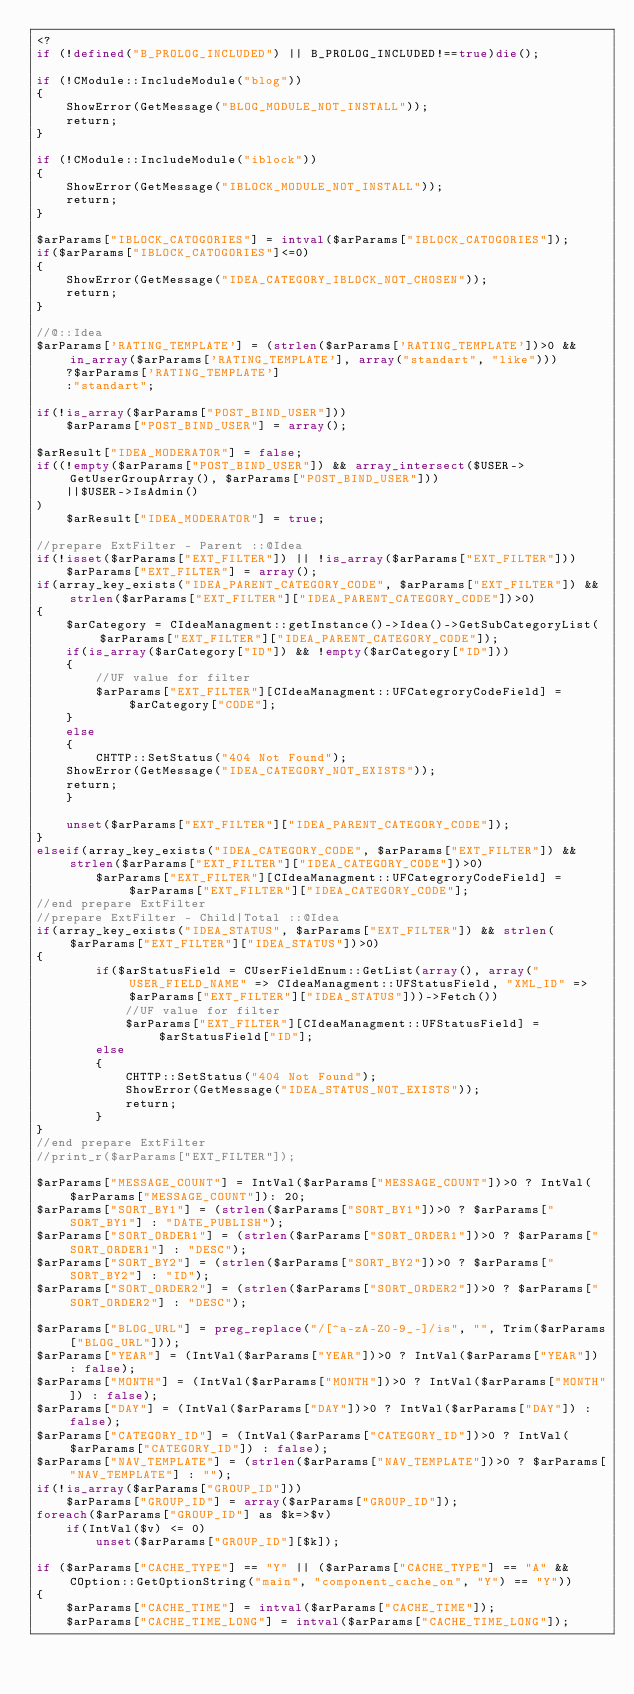<code> <loc_0><loc_0><loc_500><loc_500><_PHP_><?
if (!defined("B_PROLOG_INCLUDED") || B_PROLOG_INCLUDED!==true)die();

if (!CModule::IncludeModule("blog"))
{
	ShowError(GetMessage("BLOG_MODULE_NOT_INSTALL"));
	return;
}

if (!CModule::IncludeModule("iblock"))
{
	ShowError(GetMessage("IBLOCK_MODULE_NOT_INSTALL"));
	return;
}

$arParams["IBLOCK_CATOGORIES"] = intval($arParams["IBLOCK_CATOGORIES"]);
if($arParams["IBLOCK_CATOGORIES"]<=0)
{
	ShowError(GetMessage("IDEA_CATEGORY_IBLOCK_NOT_CHOSEN"));
	return;
}

//@::Idea
$arParams['RATING_TEMPLATE'] = (strlen($arParams['RATING_TEMPLATE'])>0 && in_array($arParams['RATING_TEMPLATE'], array("standart", "like")))
    ?$arParams['RATING_TEMPLATE']
    :"standart";

if(!is_array($arParams["POST_BIND_USER"]))
    $arParams["POST_BIND_USER"] = array();

$arResult["IDEA_MODERATOR"] = false;
if((!empty($arParams["POST_BIND_USER"]) && array_intersect($USER->GetUserGroupArray(), $arParams["POST_BIND_USER"]))
    ||$USER->IsAdmin()
)
    $arResult["IDEA_MODERATOR"] = true;

//prepare ExtFilter - Parent ::@Idea
if(!isset($arParams["EXT_FILTER"]) || !is_array($arParams["EXT_FILTER"]))
    $arParams["EXT_FILTER"] = array();
if(array_key_exists("IDEA_PARENT_CATEGORY_CODE", $arParams["EXT_FILTER"]) && strlen($arParams["EXT_FILTER"]["IDEA_PARENT_CATEGORY_CODE"])>0)
{
    $arCategory = CIdeaManagment::getInstance()->Idea()->GetSubCategoryList($arParams["EXT_FILTER"]["IDEA_PARENT_CATEGORY_CODE"]);
    if(is_array($arCategory["ID"]) && !empty($arCategory["ID"]))
    {
        //UF value for filter
        $arParams["EXT_FILTER"][CIdeaManagment::UFCategroryCodeField] = $arCategory["CODE"];
    }
    else
    {
        CHTTP::SetStatus("404 Not Found");
	ShowError(GetMessage("IDEA_CATEGORY_NOT_EXISTS"));
	return;
    }

    unset($arParams["EXT_FILTER"]["IDEA_PARENT_CATEGORY_CODE"]);
}
elseif(array_key_exists("IDEA_CATEGORY_CODE", $arParams["EXT_FILTER"]) && strlen($arParams["EXT_FILTER"]["IDEA_CATEGORY_CODE"])>0)
        $arParams["EXT_FILTER"][CIdeaManagment::UFCategroryCodeField] = $arParams["EXT_FILTER"]["IDEA_CATEGORY_CODE"];
//end prepare ExtFilter
//prepare ExtFilter - Child|Total ::@Idea
if(array_key_exists("IDEA_STATUS", $arParams["EXT_FILTER"]) && strlen($arParams["EXT_FILTER"]["IDEA_STATUS"])>0)
{ 
        if($arStatusField = CUserFieldEnum::GetList(array(), array("USER_FIELD_NAME" => CIdeaManagment::UFStatusField, "XML_ID" => $arParams["EXT_FILTER"]["IDEA_STATUS"]))->Fetch())
            //UF value for filter
            $arParams["EXT_FILTER"][CIdeaManagment::UFStatusField] = $arStatusField["ID"];
        else
        {
            CHTTP::SetStatus("404 Not Found");
            ShowError(GetMessage("IDEA_STATUS_NOT_EXISTS"));
            return;         
        }
}
//end prepare ExtFilter
//print_r($arParams["EXT_FILTER"]);

$arParams["MESSAGE_COUNT"] = IntVal($arParams["MESSAGE_COUNT"])>0 ? IntVal($arParams["MESSAGE_COUNT"]): 20;
$arParams["SORT_BY1"] = (strlen($arParams["SORT_BY1"])>0 ? $arParams["SORT_BY1"] : "DATE_PUBLISH");
$arParams["SORT_ORDER1"] = (strlen($arParams["SORT_ORDER1"])>0 ? $arParams["SORT_ORDER1"] : "DESC");
$arParams["SORT_BY2"] = (strlen($arParams["SORT_BY2"])>0 ? $arParams["SORT_BY2"] : "ID");
$arParams["SORT_ORDER2"] = (strlen($arParams["SORT_ORDER2"])>0 ? $arParams["SORT_ORDER2"] : "DESC");

$arParams["BLOG_URL"] = preg_replace("/[^a-zA-Z0-9_-]/is", "", Trim($arParams["BLOG_URL"]));
$arParams["YEAR"] = (IntVal($arParams["YEAR"])>0 ? IntVal($arParams["YEAR"]) : false);
$arParams["MONTH"] = (IntVal($arParams["MONTH"])>0 ? IntVal($arParams["MONTH"]) : false);
$arParams["DAY"] = (IntVal($arParams["DAY"])>0 ? IntVal($arParams["DAY"]) : false);
$arParams["CATEGORY_ID"] = (IntVal($arParams["CATEGORY_ID"])>0 ? IntVal($arParams["CATEGORY_ID"]) : false);
$arParams["NAV_TEMPLATE"] = (strlen($arParams["NAV_TEMPLATE"])>0 ? $arParams["NAV_TEMPLATE"] : "");
if(!is_array($arParams["GROUP_ID"]))
	$arParams["GROUP_ID"] = array($arParams["GROUP_ID"]);
foreach($arParams["GROUP_ID"] as $k=>$v)
	if(IntVal($v) <= 0)
		unset($arParams["GROUP_ID"][$k]);

if ($arParams["CACHE_TYPE"] == "Y" || ($arParams["CACHE_TYPE"] == "A" && COption::GetOptionString("main", "component_cache_on", "Y") == "Y"))
{
	$arParams["CACHE_TIME"] = intval($arParams["CACHE_TIME"]);
	$arParams["CACHE_TIME_LONG"] = intval($arParams["CACHE_TIME_LONG"]);</code> 